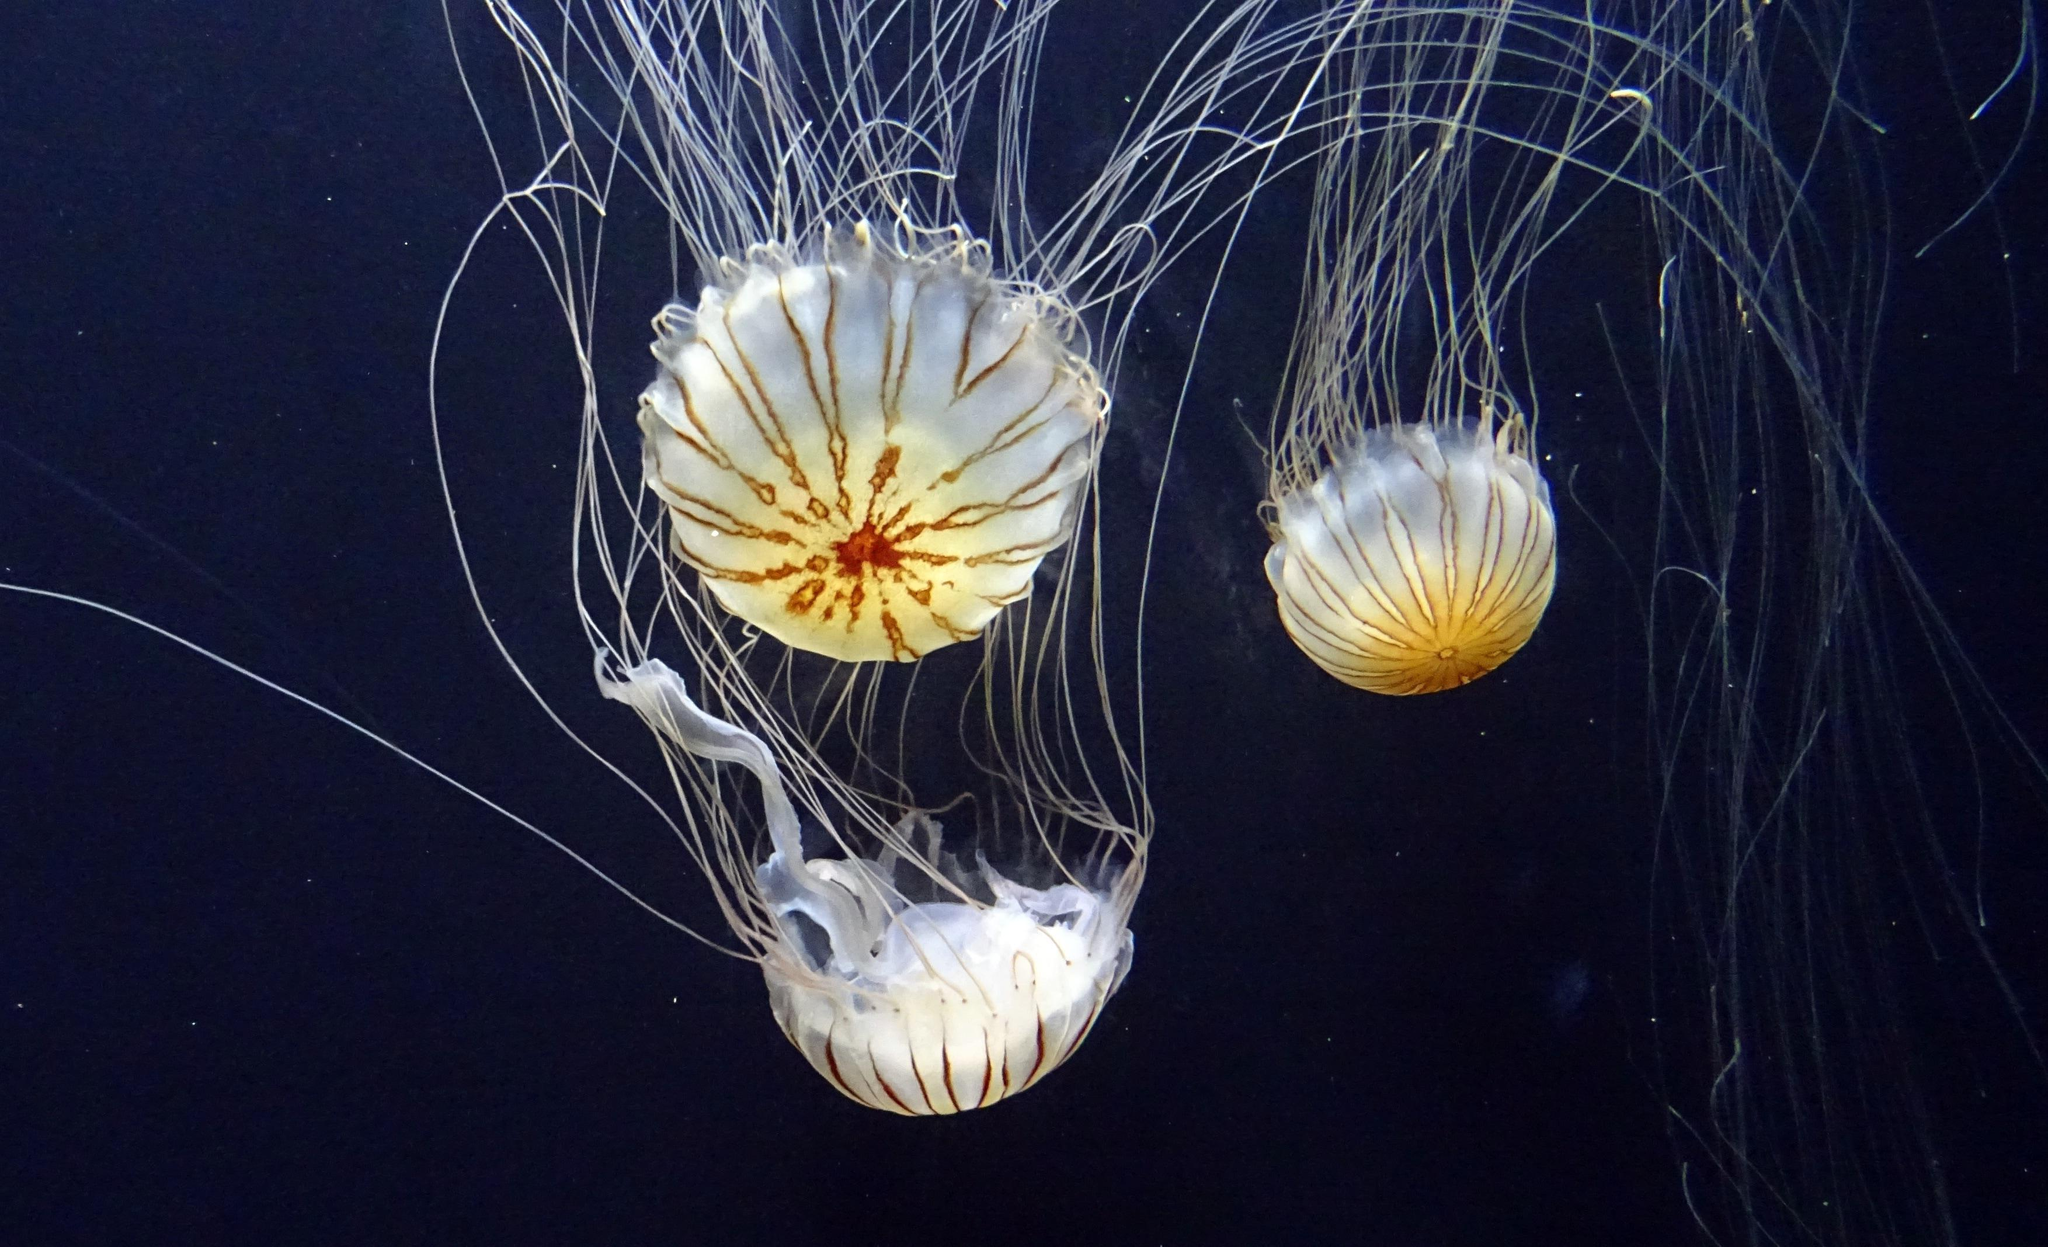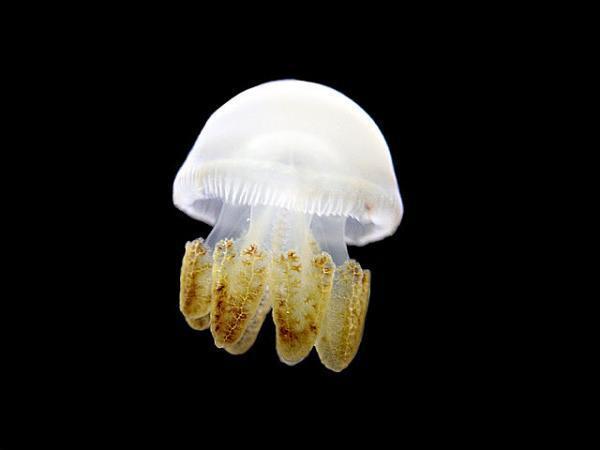The first image is the image on the left, the second image is the image on the right. Evaluate the accuracy of this statement regarding the images: "Each of the images shows a single jellyfish that has been photographed in a dark part of ocean where there is little or no light.". Is it true? Answer yes or no. No. 